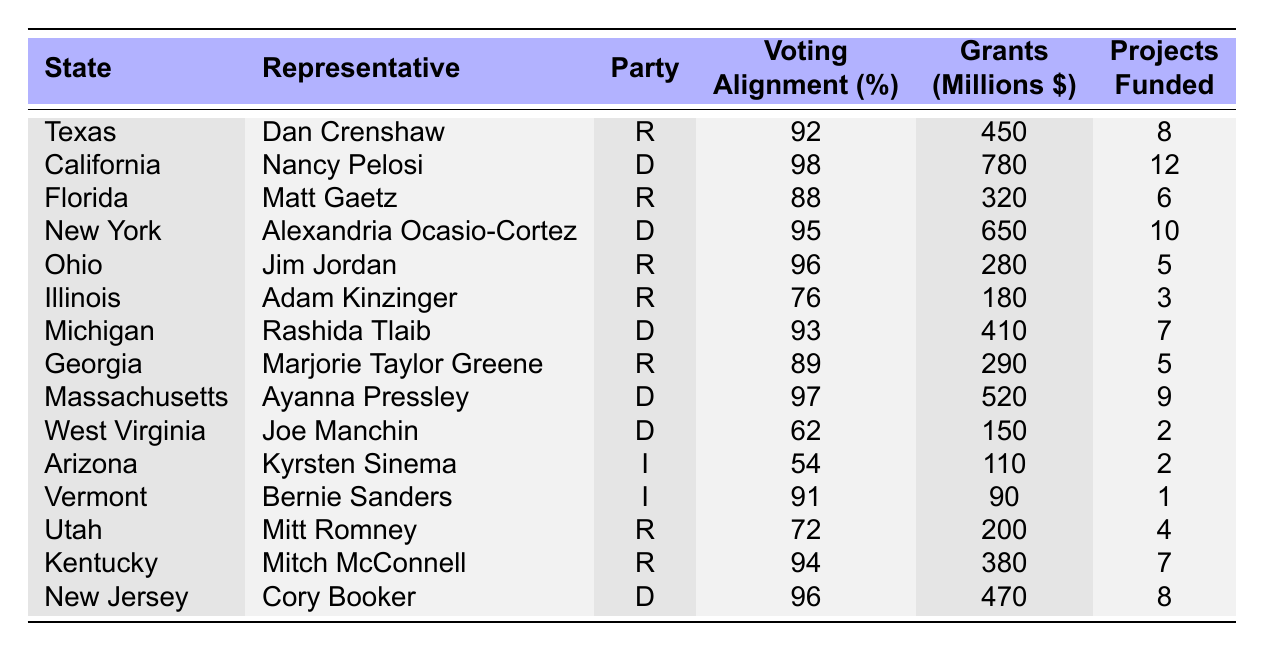What is the total amount of infrastructure grants approved for Republican representatives? The Republican representatives and their approved grants are: Dan Crenshaw (450 million), Matt Gaetz (320 million), Jim Jordan (280 million), Adam Kinzinger (180 million), Marjorie Taylor Greene (290 million), Mitt Romney (200 million), and Mitch McConnell (380 million). Adding these amounts: 450 + 320 + 280 + 180 + 290 + 200 + 380 = 2100 million.
Answer: 2100 million Which state received the highest amount in infrastructure grants? Looking through the table, California, represented by Nancy Pelosi, has the highest amount of infrastructure grants at 780 million dollars.
Answer: California How many projects were funded in total by Democrat representatives? The Democrat representatives and the number of projects funded are: Nancy Pelosi (12), Alexandria Ocasio-Cortez (10), Rashida Tlaib (7), Ayanna Pressley (9), Joe Manchin (2), and Cory Booker (8). Adding these gives: 12 + 10 + 7 + 9 + 2 + 8 = 48 projects.
Answer: 48 projects Is there any representative who aligned less than 70% with the voting majority? Checking the table, Kyrsten Sinema (54%) and Adam Kinzinger (76%) aligned less than 70% with the voting majority, with Sinema being below 70%. Therefore, yes, there are representatives with less than 70% alignment.
Answer: Yes What is the average voting alignment percentage for all representatives? To find the average, we sum the voting alignment percentages: 92 + 98 + 88 + 95 + 96 + 76 + 93 + 89 + 97 + 62 + 54 + 91 + 72 + 94 + 96 = 1390, and since there are 15 representatives, we divide by 15. So, average = 1390 / 15 = 92.67.
Answer: 92.67 How many Republicans have more than 400 million in approved infrastructure grants? Reviewing the table for Republicans, Dan Crenshaw (450 million), Matt Gaetz (320 million), and Mitch McConnell (380 million) show that only Dan Crenshaw is above 400 million. Thus, there is 1 Republican representative with more than 400 million.
Answer: 1 Republican Which political party has a higher average value of infrastructure grants approved? The average for Democrats: 780 + 650 + 410 + 520 + 150 + 470 = 3180 for 6 representatives, average = 3180/6 = 530 million. For Republicans: 450 + 320 + 280 + 180 + 290 + 200 + 380 = 2100 for 7 representatives, average = 2100/7 = 300 million. Democrats have a higher average of 530 million compared to 300 million for Republicans.
Answer: Democrats Does the representative with the least projects funded also belong to the Democratic party? The table shows that Joe Manchin funded 2 projects, while the lowest overall is Bernie Sanders, an independent, with only 1 project funded. Hence, the least funded representative is not a Democrat.
Answer: No 